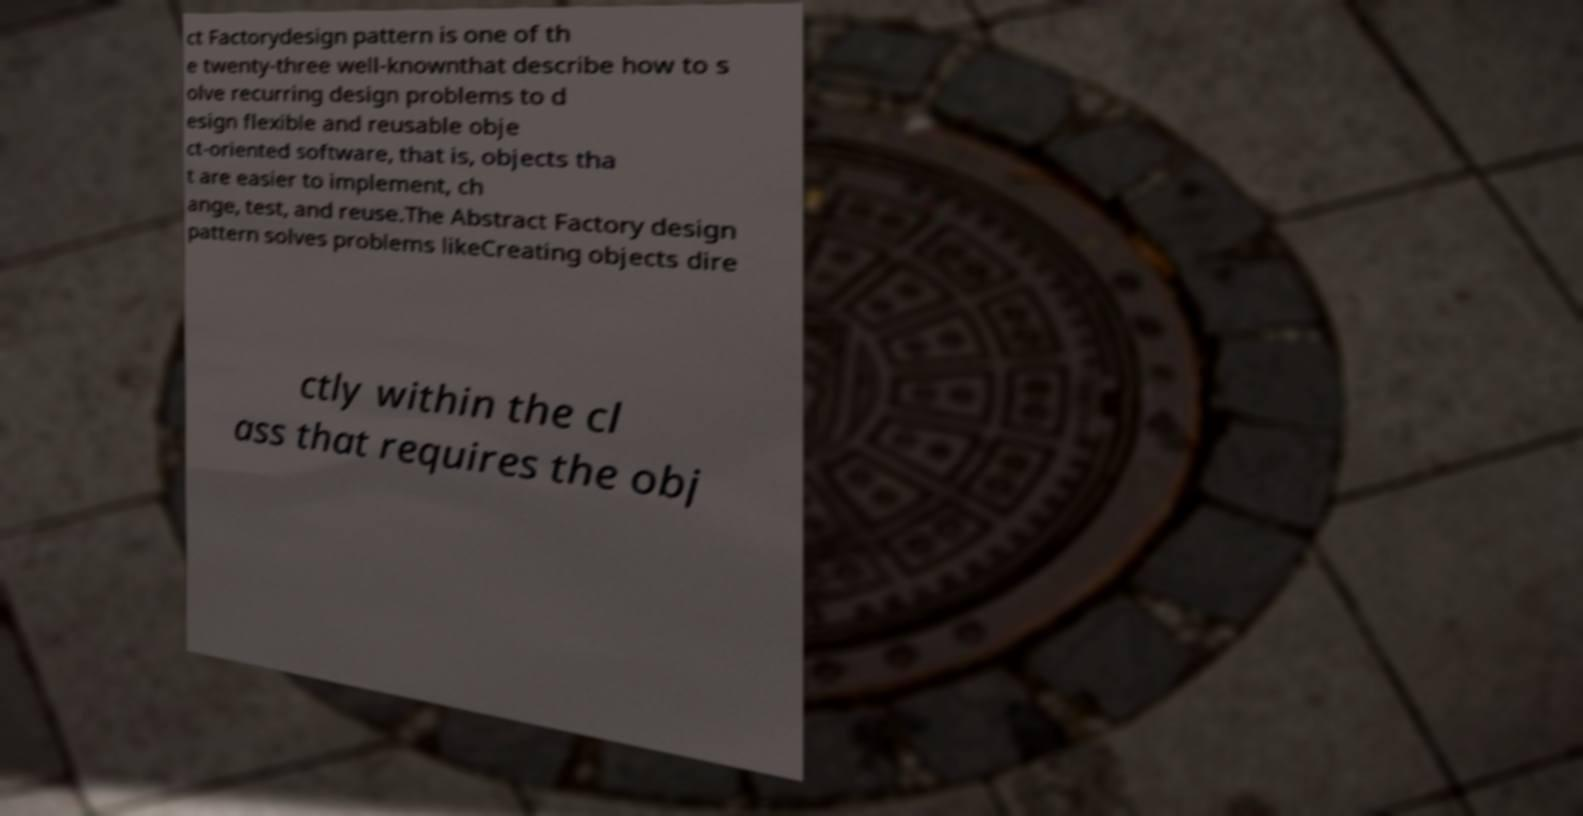Can you read and provide the text displayed in the image?This photo seems to have some interesting text. Can you extract and type it out for me? ct Factorydesign pattern is one of th e twenty-three well-knownthat describe how to s olve recurring design problems to d esign flexible and reusable obje ct-oriented software, that is, objects tha t are easier to implement, ch ange, test, and reuse.The Abstract Factory design pattern solves problems likeCreating objects dire ctly within the cl ass that requires the obj 